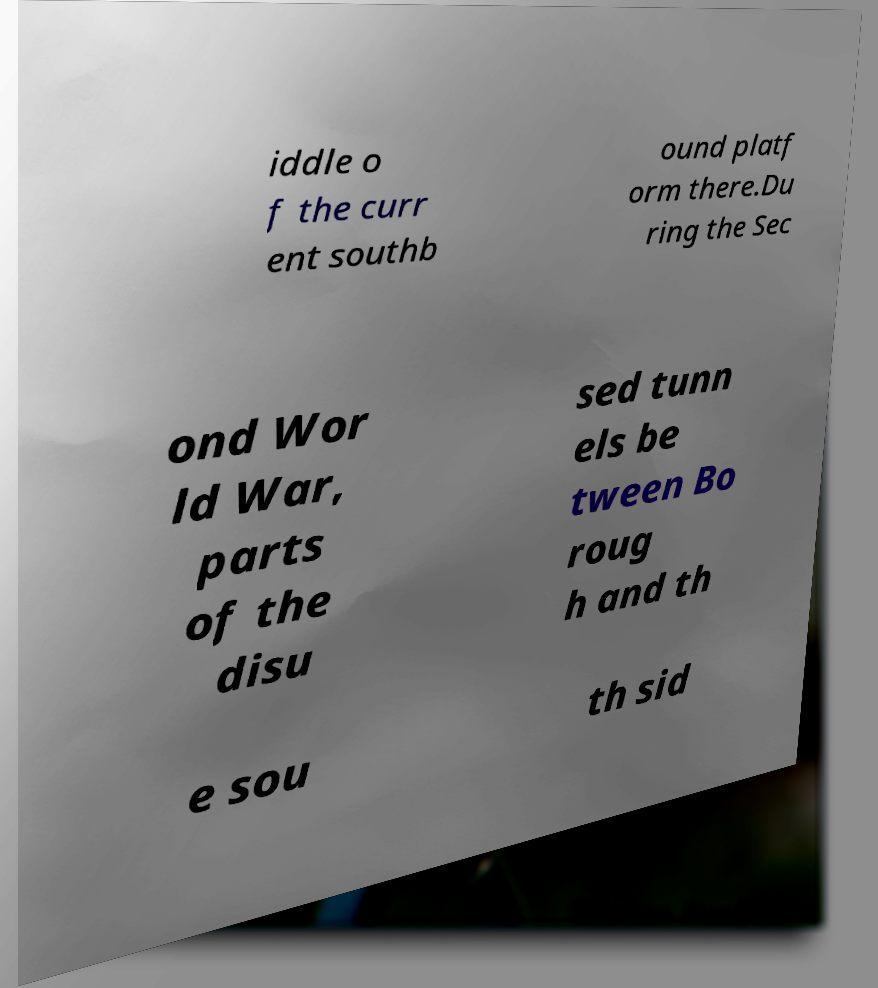Can you accurately transcribe the text from the provided image for me? iddle o f the curr ent southb ound platf orm there.Du ring the Sec ond Wor ld War, parts of the disu sed tunn els be tween Bo roug h and th e sou th sid 